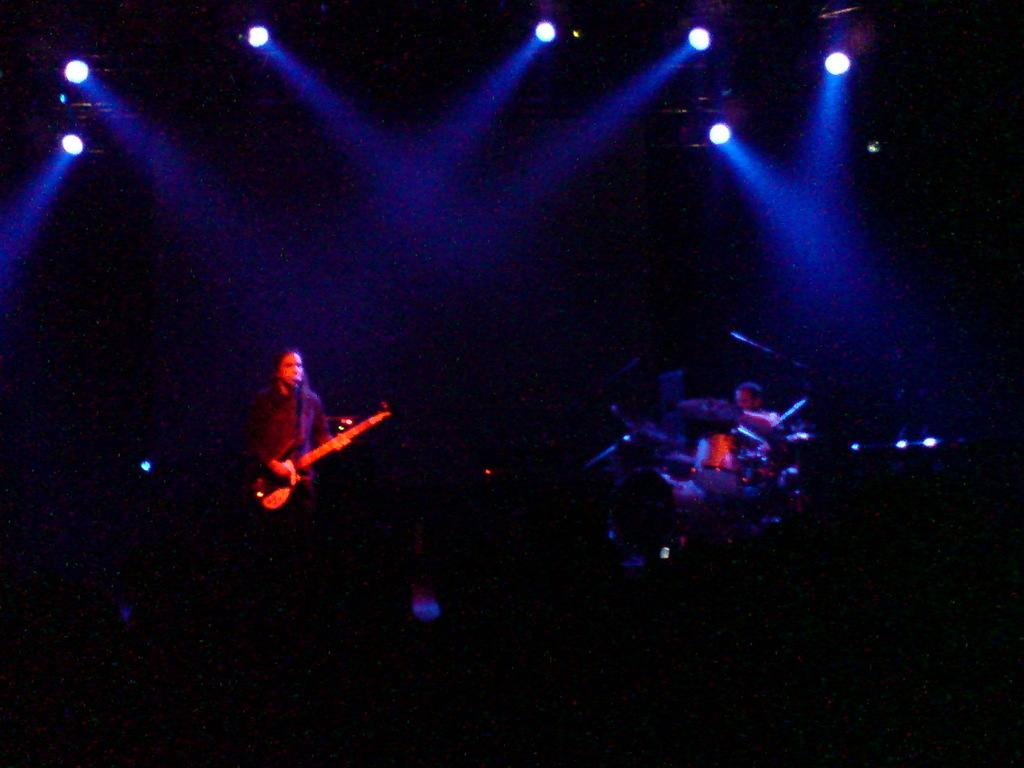How many people are in the image? There are persons in the image, but the exact number is not specified. What are the persons doing in the image? The persons are likely playing musical instruments, as they are mentioned as being present in the image. What can be seen in the background of the image? There are lights visible in the background of the image. What type of thread is being used to create the thrilling atmosphere in the image? There is no mention of thread or a thrilling atmosphere in the image, so this question cannot be answered definitively. 